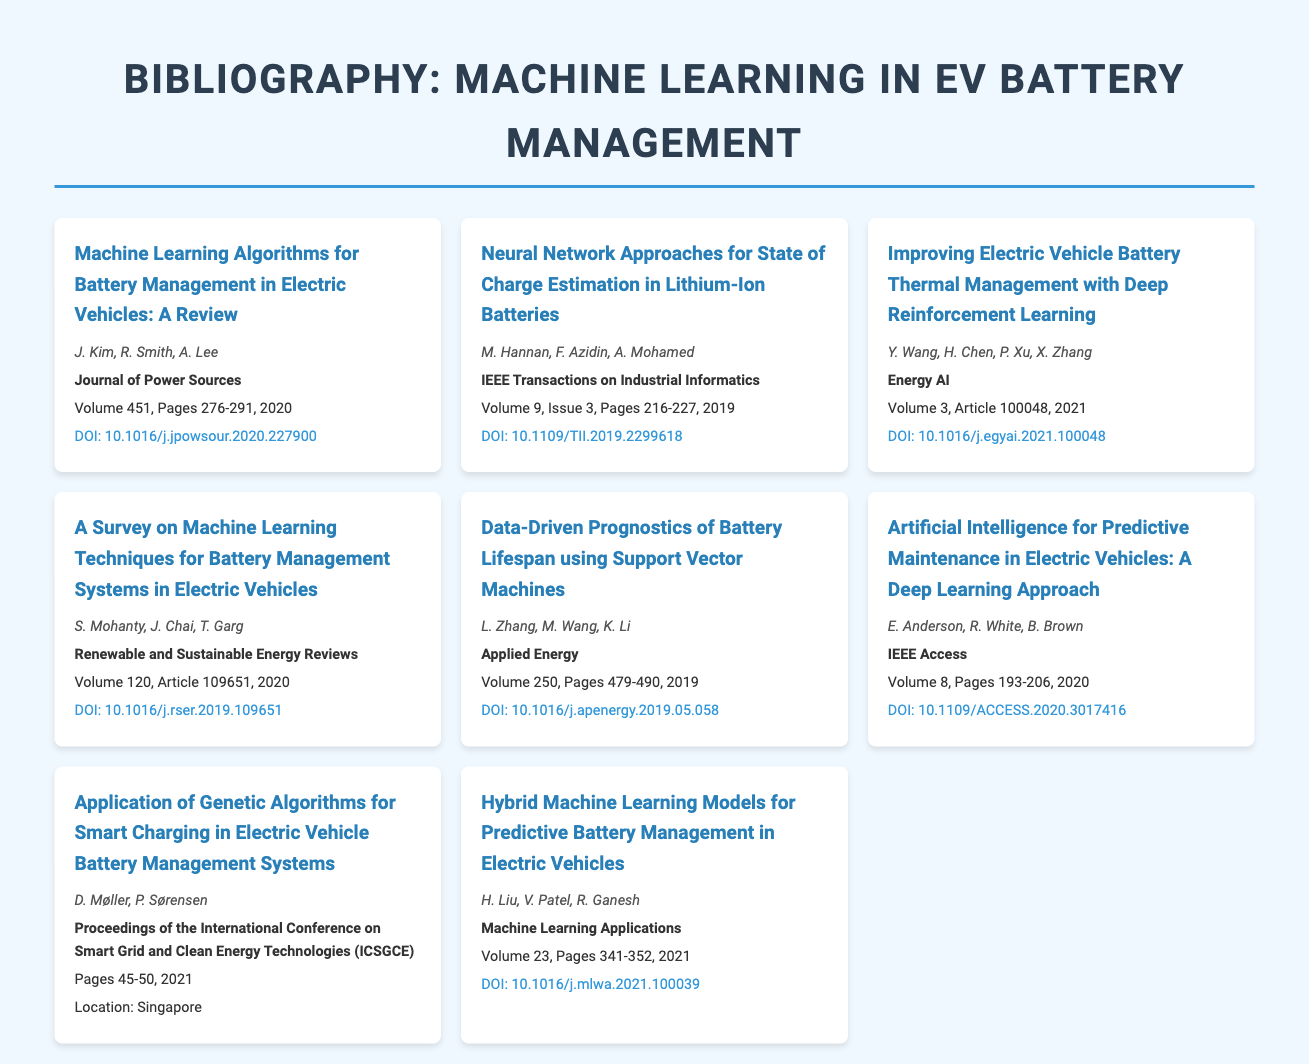what is the title of the first entry? The title of the first entry is the phrase found at the beginning of the first bibliographic entry.
Answer: Machine Learning Algorithms for Battery Management in Electric Vehicles: A Review who are the authors of the paper published in the IEEE Transactions on Industrial Informatics? The authors are listed right below the title of the corresponding entry.
Answer: M. Hannan, F. Azidin, A. Mohamed in which journal was the article about improving battery thermal management published? The journal name is mentioned in bold below the authors in the corresponding entry.
Answer: Energy AI what year was the survey on machine learning techniques for battery management systems published? The publication date can be found in the text detailing each bibliographic entry.
Answer: 2020 how many pages does the article on data-driven prognostics of battery lifespan cover? The total number of pages is specified in the bibliographic entry.
Answer: 479-490 what is the DOI for the paper about artificial intelligence for predictive maintenance in electric vehicles? The DOI is a specific identifier mentioned at the end of each entry.
Answer: 10.1109/ACCESS.2020.3017416 which conference proceedings is the entry for smart charging associated with? The conference name is stated in the title of the corresponding entry.
Answer: Proceedings of the International Conference on Smart Grid and Clean Energy Technologies (ICSGCE) how many entries are included in the bibliography? The count of entries can be determined by counting the individual bibliographic entries in the document.
Answer: 8 